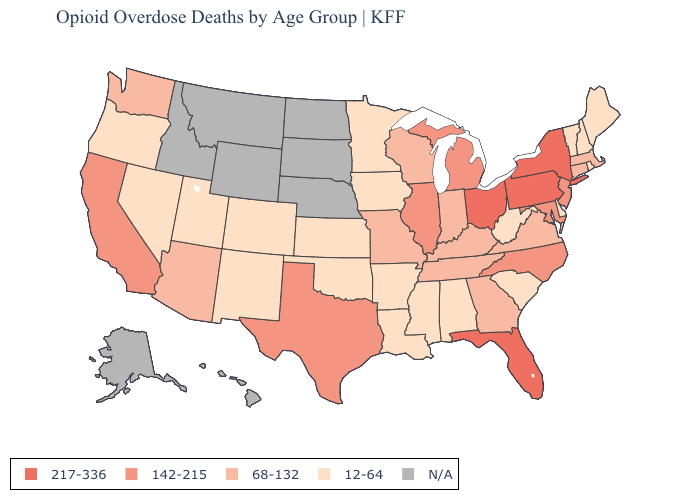What is the highest value in states that border Georgia?
Keep it brief. 217-336. Name the states that have a value in the range N/A?
Be succinct. Alaska, Hawaii, Idaho, Montana, Nebraska, North Dakota, South Dakota, Wyoming. Name the states that have a value in the range 142-215?
Write a very short answer. California, Illinois, Maryland, Michigan, New Jersey, North Carolina, Texas. Name the states that have a value in the range 68-132?
Concise answer only. Arizona, Connecticut, Georgia, Indiana, Kentucky, Massachusetts, Missouri, Tennessee, Virginia, Washington, Wisconsin. Name the states that have a value in the range N/A?
Be succinct. Alaska, Hawaii, Idaho, Montana, Nebraska, North Dakota, South Dakota, Wyoming. Does the first symbol in the legend represent the smallest category?
Quick response, please. No. What is the lowest value in states that border Delaware?
Short answer required. 142-215. What is the highest value in states that border Nevada?
Concise answer only. 142-215. Name the states that have a value in the range 217-336?
Be succinct. Florida, New York, Ohio, Pennsylvania. Which states hav the highest value in the Northeast?
Concise answer only. New York, Pennsylvania. What is the highest value in states that border Mississippi?
Write a very short answer. 68-132. What is the value of Minnesota?
Write a very short answer. 12-64. Name the states that have a value in the range 12-64?
Answer briefly. Alabama, Arkansas, Colorado, Delaware, Iowa, Kansas, Louisiana, Maine, Minnesota, Mississippi, Nevada, New Hampshire, New Mexico, Oklahoma, Oregon, Rhode Island, South Carolina, Utah, Vermont, West Virginia. Does the first symbol in the legend represent the smallest category?
Write a very short answer. No. 